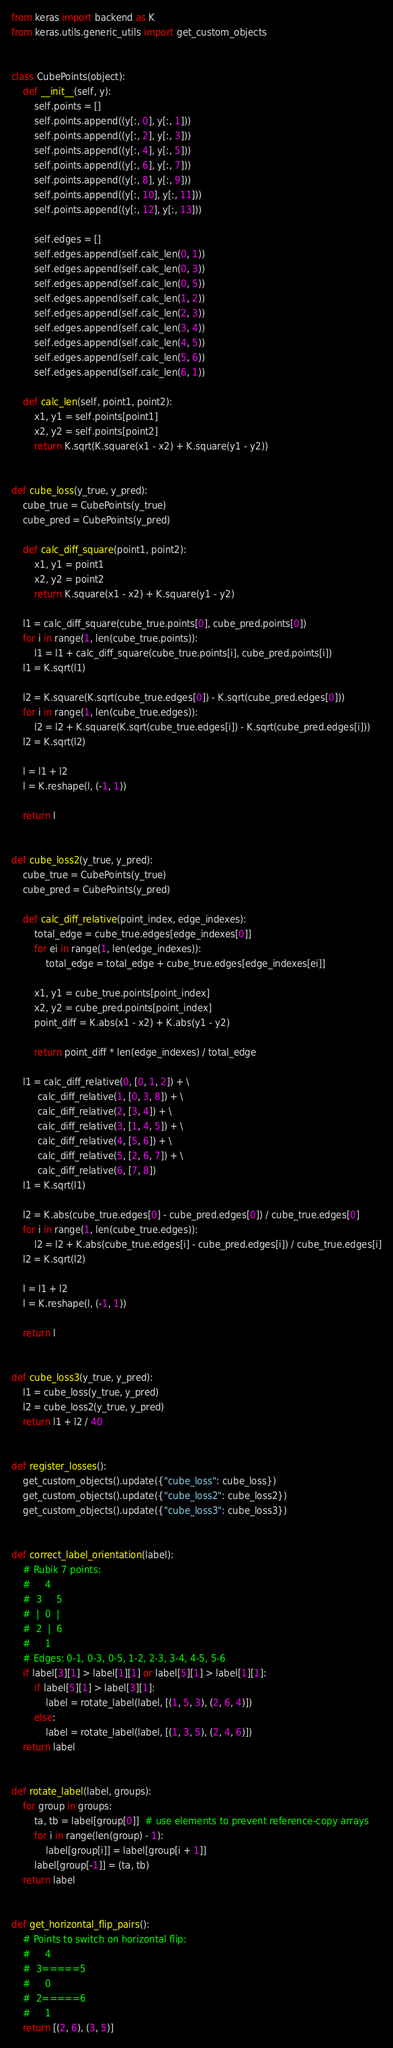<code> <loc_0><loc_0><loc_500><loc_500><_Python_>from keras import backend as K
from keras.utils.generic_utils import get_custom_objects


class CubePoints(object):
    def __init__(self, y):
        self.points = []
        self.points.append((y[:, 0], y[:, 1]))
        self.points.append((y[:, 2], y[:, 3]))
        self.points.append((y[:, 4], y[:, 5]))
        self.points.append((y[:, 6], y[:, 7]))
        self.points.append((y[:, 8], y[:, 9]))
        self.points.append((y[:, 10], y[:, 11]))
        self.points.append((y[:, 12], y[:, 13]))

        self.edges = []
        self.edges.append(self.calc_len(0, 1))
        self.edges.append(self.calc_len(0, 3))
        self.edges.append(self.calc_len(0, 5))
        self.edges.append(self.calc_len(1, 2))
        self.edges.append(self.calc_len(2, 3))
        self.edges.append(self.calc_len(3, 4))
        self.edges.append(self.calc_len(4, 5))
        self.edges.append(self.calc_len(5, 6))
        self.edges.append(self.calc_len(6, 1))

    def calc_len(self, point1, point2):
        x1, y1 = self.points[point1]
        x2, y2 = self.points[point2]
        return K.sqrt(K.square(x1 - x2) + K.square(y1 - y2))


def cube_loss(y_true, y_pred):
    cube_true = CubePoints(y_true)
    cube_pred = CubePoints(y_pred)

    def calc_diff_square(point1, point2):
        x1, y1 = point1
        x2, y2 = point2
        return K.square(x1 - x2) + K.square(y1 - y2)

    l1 = calc_diff_square(cube_true.points[0], cube_pred.points[0])
    for i in range(1, len(cube_true.points)):
        l1 = l1 + calc_diff_square(cube_true.points[i], cube_pred.points[i])
    l1 = K.sqrt(l1)

    l2 = K.square(K.sqrt(cube_true.edges[0]) - K.sqrt(cube_pred.edges[0]))
    for i in range(1, len(cube_true.edges)):
        l2 = l2 + K.square(K.sqrt(cube_true.edges[i]) - K.sqrt(cube_pred.edges[i]))
    l2 = K.sqrt(l2)

    l = l1 + l2
    l = K.reshape(l, (-1, 1))

    return l


def cube_loss2(y_true, y_pred):
    cube_true = CubePoints(y_true)
    cube_pred = CubePoints(y_pred)

    def calc_diff_relative(point_index, edge_indexes):
        total_edge = cube_true.edges[edge_indexes[0]]
        for ei in range(1, len(edge_indexes)):
            total_edge = total_edge + cube_true.edges[edge_indexes[ei]]

        x1, y1 = cube_true.points[point_index]
        x2, y2 = cube_pred.points[point_index]
        point_diff = K.abs(x1 - x2) + K.abs(y1 - y2)

        return point_diff * len(edge_indexes) / total_edge

    l1 = calc_diff_relative(0, [0, 1, 2]) + \
         calc_diff_relative(1, [0, 3, 8]) + \
         calc_diff_relative(2, [3, 4]) + \
         calc_diff_relative(3, [1, 4, 5]) + \
         calc_diff_relative(4, [5, 6]) + \
         calc_diff_relative(5, [2, 6, 7]) + \
         calc_diff_relative(6, [7, 8])
    l1 = K.sqrt(l1)

    l2 = K.abs(cube_true.edges[0] - cube_pred.edges[0]) / cube_true.edges[0]
    for i in range(1, len(cube_true.edges)):
        l2 = l2 + K.abs(cube_true.edges[i] - cube_pred.edges[i]) / cube_true.edges[i]
    l2 = K.sqrt(l2)

    l = l1 + l2
    l = K.reshape(l, (-1, 1))

    return l


def cube_loss3(y_true, y_pred):
    l1 = cube_loss(y_true, y_pred)
    l2 = cube_loss2(y_true, y_pred)
    return l1 + l2 / 40


def register_losses():
    get_custom_objects().update({"cube_loss": cube_loss})
    get_custom_objects().update({"cube_loss2": cube_loss2})
    get_custom_objects().update({"cube_loss3": cube_loss3})


def correct_label_orientation(label):
    # Rubik 7 points:
    #     4
    #  3     5
    #  |  0  |
    #  2  |  6
    #     1
    # Edges: 0-1, 0-3, 0-5, 1-2, 2-3, 3-4, 4-5, 5-6
    if label[3][1] > label[1][1] or label[5][1] > label[1][1]:
        if label[5][1] > label[3][1]:
            label = rotate_label(label, [(1, 5, 3), (2, 6, 4)])
        else:
            label = rotate_label(label, [(1, 3, 5), (2, 4, 6)])
    return label


def rotate_label(label, groups):
    for group in groups:
        ta, tb = label[group[0]]  # use elements to prevent reference-copy arrays
        for i in range(len(group) - 1):
            label[group[i]] = label[group[i + 1]]
        label[group[-1]] = (ta, tb)
    return label


def get_horizontal_flip_pairs():
    # Points to switch on horizontal flip:
    #     4
    #  3=====5
    #     0
    #  2=====6
    #     1
    return [(2, 6), (3, 5)]
</code> 